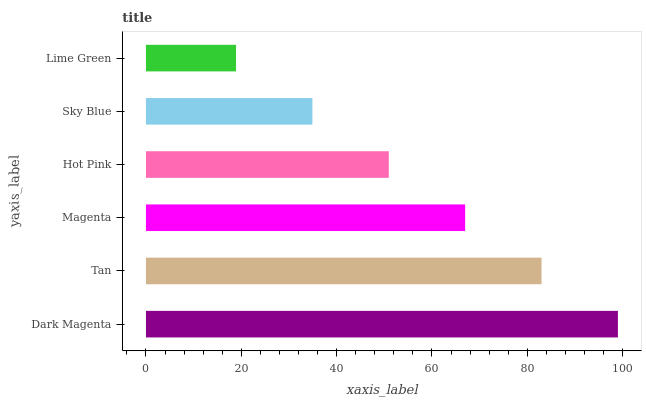Is Lime Green the minimum?
Answer yes or no. Yes. Is Dark Magenta the maximum?
Answer yes or no. Yes. Is Tan the minimum?
Answer yes or no. No. Is Tan the maximum?
Answer yes or no. No. Is Dark Magenta greater than Tan?
Answer yes or no. Yes. Is Tan less than Dark Magenta?
Answer yes or no. Yes. Is Tan greater than Dark Magenta?
Answer yes or no. No. Is Dark Magenta less than Tan?
Answer yes or no. No. Is Magenta the high median?
Answer yes or no. Yes. Is Hot Pink the low median?
Answer yes or no. Yes. Is Sky Blue the high median?
Answer yes or no. No. Is Lime Green the low median?
Answer yes or no. No. 